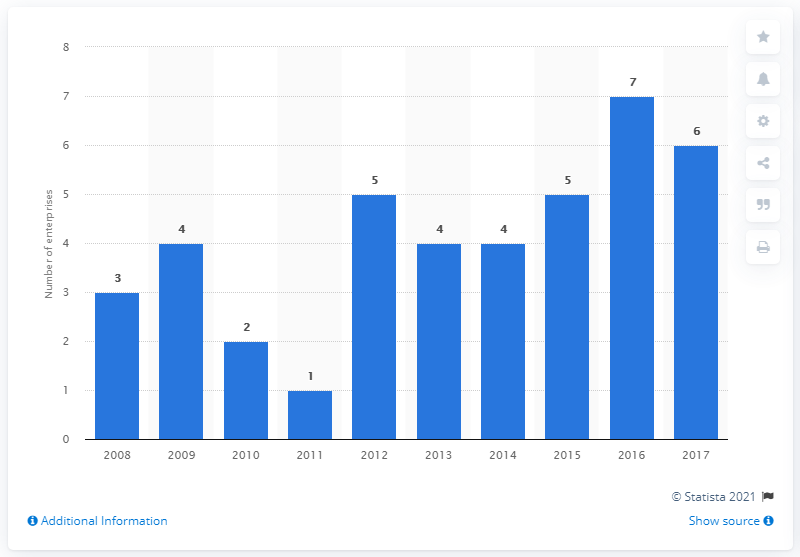What is the average of the two modes? The histogram clearly shows two modes at the values of 4 and 5, which are the most frequently occurring numbers in the dataset presented. Calculating the average of these two modes, we add them together to get 9, and then divide by 2 to obtain 4.5. Therefore, the average of the two modes in this data is 4.5. 